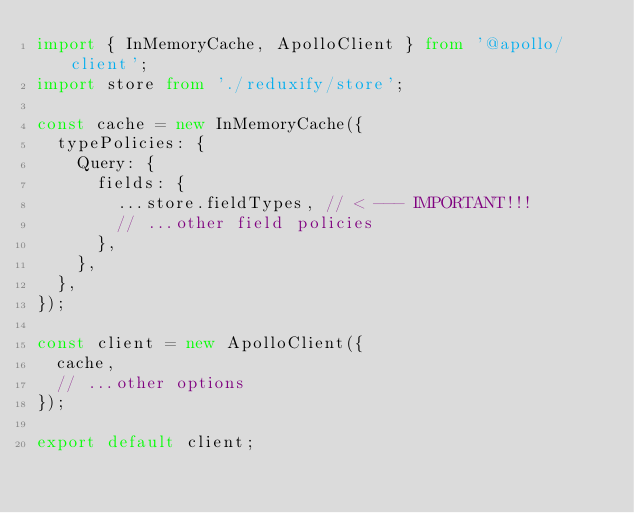<code> <loc_0><loc_0><loc_500><loc_500><_TypeScript_>import { InMemoryCache, ApolloClient } from '@apollo/client';
import store from './reduxify/store';

const cache = new InMemoryCache({
  typePolicies: {
    Query: {
      fields: {
        ...store.fieldTypes, // < --- IMPORTANT!!!
        // ...other field policies
      },
    },
  },
});

const client = new ApolloClient({
  cache,
  // ...other options
});

export default client;
</code> 